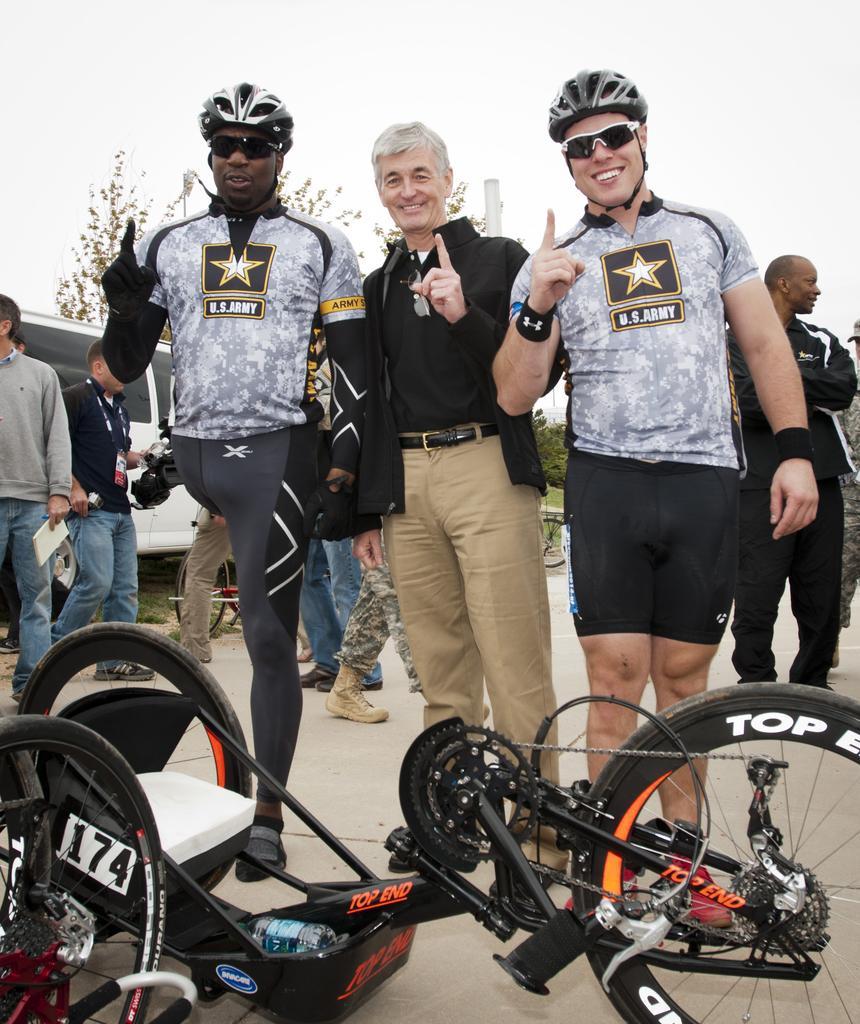How would you summarize this image in a sentence or two? In this image, in the middle, we can see three men are standing on the land. In the middle, we can also see a bicycle. In the background, we can see a group of people and a vehicle, trees, pole. At the top, we can see a sky which is cloudy. 